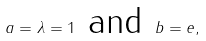Convert formula to latex. <formula><loc_0><loc_0><loc_500><loc_500>a = \lambda = 1 \text { and } b = e ,</formula> 